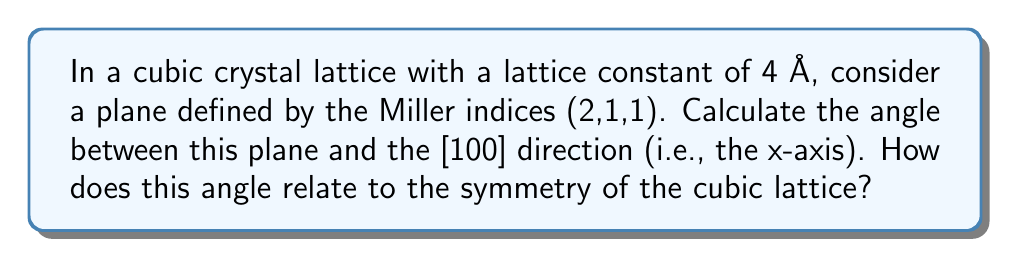Help me with this question. Let's approach this step-by-step:

1) First, recall that for a cubic lattice, the direction [hkl] is perpendicular to the plane (hkl). So, we need to find the angle between [211] and [100].

2) The angle θ between two directions [u₁v₁w₁] and [u₂v₂w₂] in a cubic crystal is given by:

   $$\cos \theta = \frac{u_1u_2 + v_1v_2 + w_1w_2}{\sqrt{(u_1^2 + v_1^2 + w_1^2)(u_2^2 + v_2^2 + w_2^2)}}$$

3) In our case, [u₁v₁w₁] = [211] and [u₂v₂w₂] = [100]. Substituting these values:

   $$\cos \theta = \frac{2(1) + 1(0) + 1(0)}{\sqrt{(2^2 + 1^2 + 1^2)(1^2 + 0^2 + 0^2)}}$$

4) Simplify:

   $$\cos \theta = \frac{2}{\sqrt{6 \cdot 1}} = \frac{2}{\sqrt{6}} = \frac{2\sqrt{6}}{6} = \frac{\sqrt{6}}{3}$$

5) To find θ, we take the inverse cosine (arccos):

   $$\theta = \arccos(\frac{\sqrt{6}}{3}) \approx 35.26°$$

6) This angle is significant in cubic crystal symmetry. It's the angle between a body diagonal and any face diagonal in a cube. This reflects the high degree of symmetry in cubic lattices, which have the highest symmetry of any crystal system.

7) The fact that this angle is the same for (211), (121), and (112) planes with respect to [100], [010], and [001] directions respectively, demonstrates the rotational symmetry of the cubic lattice.
Answer: The angle between the (211) plane and the [100] direction is $\arccos(\frac{\sqrt{6}}{3}) \approx 35.26°$. This angle reflects the high degree of symmetry in cubic lattices, being consistent with the angle between a body diagonal and any face diagonal in a cube. 